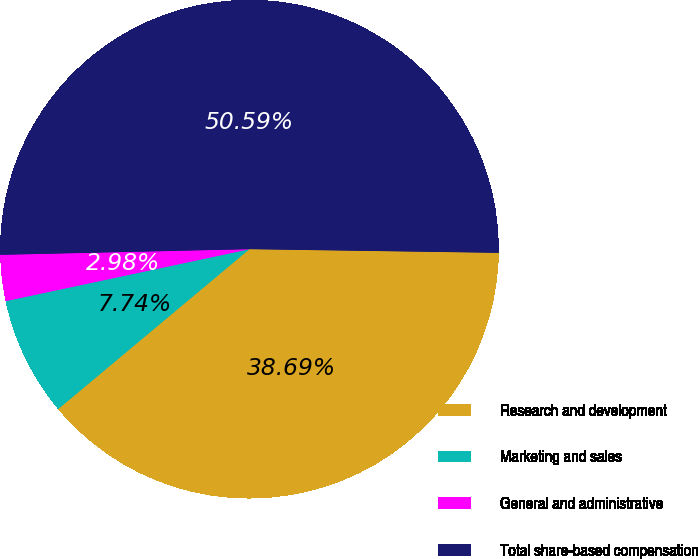Convert chart to OTSL. <chart><loc_0><loc_0><loc_500><loc_500><pie_chart><fcel>Research and development<fcel>Marketing and sales<fcel>General and administrative<fcel>Total share-based compensation<nl><fcel>38.69%<fcel>7.74%<fcel>2.98%<fcel>50.6%<nl></chart> 